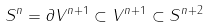Convert formula to latex. <formula><loc_0><loc_0><loc_500><loc_500>S ^ { n } = \partial V ^ { n + 1 } \subset V ^ { n + 1 } \subset S ^ { n + 2 }</formula> 